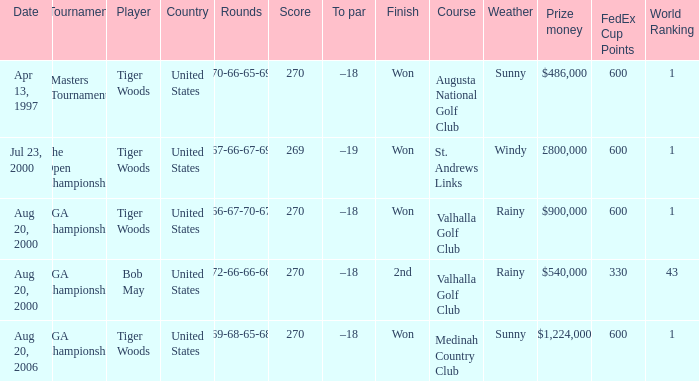What players finished 2nd? Bob May. 